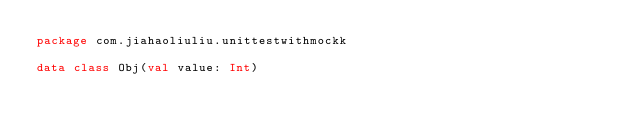<code> <loc_0><loc_0><loc_500><loc_500><_Kotlin_>package com.jiahaoliuliu.unittestwithmockk

data class Obj(val value: Int)</code> 